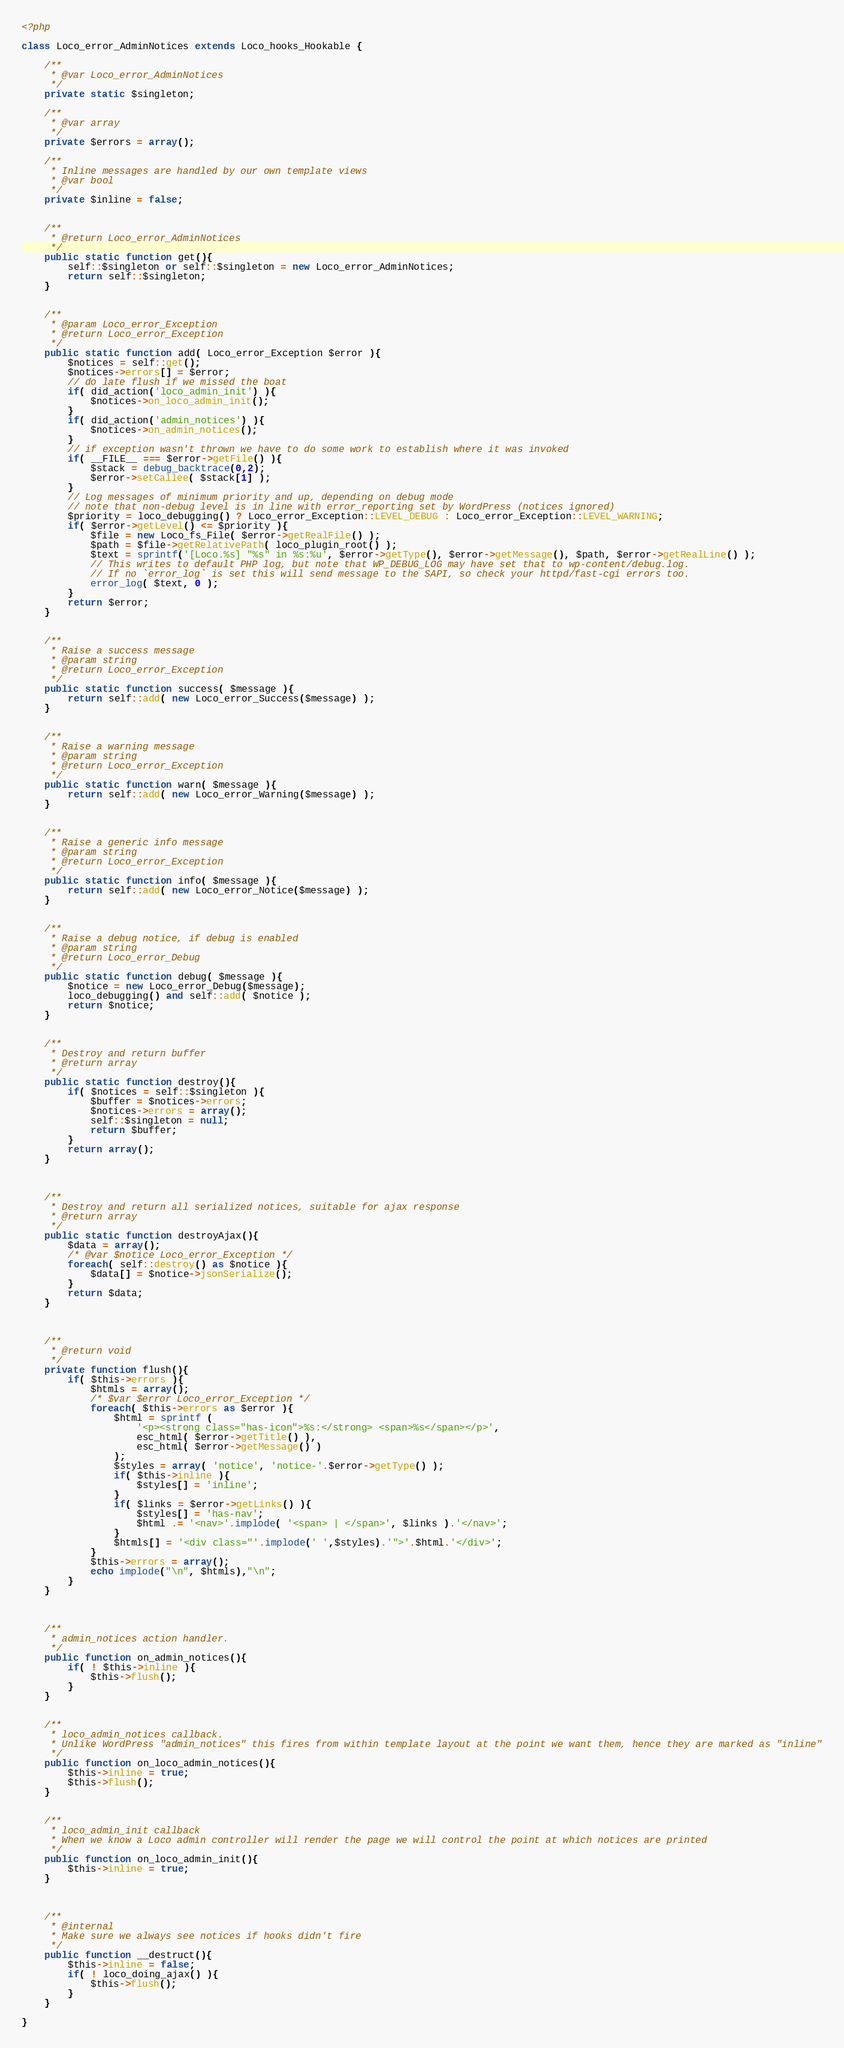<code> <loc_0><loc_0><loc_500><loc_500><_PHP_><?php

class Loco_error_AdminNotices extends Loco_hooks_Hookable {
    
    /**
     * @var Loco_error_AdminNotices
     */
    private static $singleton;

    /**
     * @var array
     */
    private $errors = array();

    /**
     * Inline messages are handled by our own template views
     * @var bool
     */
    private $inline = false;


    /**
     * @return Loco_error_AdminNotices
     */
    public static function get(){
        self::$singleton or self::$singleton = new Loco_error_AdminNotices;
        return self::$singleton;
    } 

    
    /**
     * @param Loco_error_Exception
     * @return Loco_error_Exception
     */
    public static function add( Loco_error_Exception $error ){
        $notices = self::get();
        $notices->errors[] = $error;
        // do late flush if we missed the boat
        if( did_action('loco_admin_init') ){
            $notices->on_loco_admin_init();
        }
        if( did_action('admin_notices') ){
            $notices->on_admin_notices();
        }
        // if exception wasn't thrown we have to do some work to establish where it was invoked
        if( __FILE__ === $error->getFile() ){
            $stack = debug_backtrace(0,2);
            $error->setCallee( $stack[1] );
        }
        // Log messages of minimum priority and up, depending on debug mode
        // note that non-debug level is in line with error_reporting set by WordPress (notices ignored)
        $priority = loco_debugging() ? Loco_error_Exception::LEVEL_DEBUG : Loco_error_Exception::LEVEL_WARNING;
        if( $error->getLevel() <= $priority ){
            $file = new Loco_fs_File( $error->getRealFile() );
            $path = $file->getRelativePath( loco_plugin_root() );
            $text = sprintf('[Loco.%s] "%s" in %s:%u', $error->getType(), $error->getMessage(), $path, $error->getRealLine() );
            // This writes to default PHP log, but note that WP_DEBUG_LOG may have set that to wp-content/debug.log.
            // If no `error_log` is set this will send message to the SAPI, so check your httpd/fast-cgi errors too.
            error_log( $text, 0 );
        }
        return $error;
    }


    /**
     * Raise a success message
     * @param string
     * @return Loco_error_Exception
     */
    public static function success( $message ){
        return self::add( new Loco_error_Success($message) );
    }


    /**
     * Raise a warning message
     * @param string
     * @return Loco_error_Exception
     */
    public static function warn( $message ){
        return self::add( new Loco_error_Warning($message) );
    }


    /**
     * Raise a generic info message
     * @param string
     * @return Loco_error_Exception
     */
    public static function info( $message ){
        return self::add( new Loco_error_Notice($message) );
    }


    /**
     * Raise a debug notice, if debug is enabled
     * @param string
     * @return Loco_error_Debug
     */
    public static function debug( $message ){
        $notice = new Loco_error_Debug($message);
        loco_debugging() and self::add( $notice );
        return $notice;
    }


    /**
     * Destroy and return buffer
     * @return array
     */
    public static function destroy(){
        if( $notices = self::$singleton ){
            $buffer = $notices->errors;
            $notices->errors = array();
            self::$singleton = null;
            return $buffer;
        }
        return array();
    }



    /**
     * Destroy and return all serialized notices, suitable for ajax response 
     * @return array
     */
    public static function destroyAjax(){
        $data = array();
        /* @var $notice Loco_error_Exception */
        foreach( self::destroy() as $notice ){
            $data[] = $notice->jsonSerialize();
        }
        return $data;
    }


    
    /**
     * @return void
     */
    private function flush(){
        if( $this->errors ){
            $htmls = array();
            /* $var $error Loco_error_Exception */
            foreach( $this->errors as $error ){
                $html = sprintf (
                    '<p><strong class="has-icon">%s:</strong> <span>%s</span></p>',
                    esc_html( $error->getTitle() ),
                    esc_html( $error->getMessage() )
                );
                $styles = array( 'notice', 'notice-'.$error->getType() );
                if( $this->inline ){
                    $styles[] = 'inline';
                }
                if( $links = $error->getLinks() ){
                    $styles[] = 'has-nav';
                    $html .= '<nav>'.implode( '<span> | </span>', $links ).'</nav>';
                }
                $htmls[] = '<div class="'.implode(' ',$styles).'">'.$html.'</div>';
            }
            $this->errors = array();
            echo implode("\n", $htmls),"\n";
        }
    }



    /**
     * admin_notices action handler.
     */
    public function on_admin_notices(){
        if( ! $this->inline ){
            $this->flush();
        }
    }


    /**
     * loco_admin_notices callback.
     * Unlike WordPress "admin_notices" this fires from within template layout at the point we want them, hence they are marked as "inline"
     */
    public function on_loco_admin_notices(){
        $this->inline = true;
        $this->flush();
    }


    /**
     * loco_admin_init callback
     * When we know a Loco admin controller will render the page we will control the point at which notices are printed
     */
    public function on_loco_admin_init(){
        $this->inline = true;
    }



    /**
     * @internal
     * Make sure we always see notices if hooks didn't fire
     */
    public function __destruct(){
        $this->inline = false;
        if( ! loco_doing_ajax() ){
            $this->flush();
        }
    }

}
</code> 